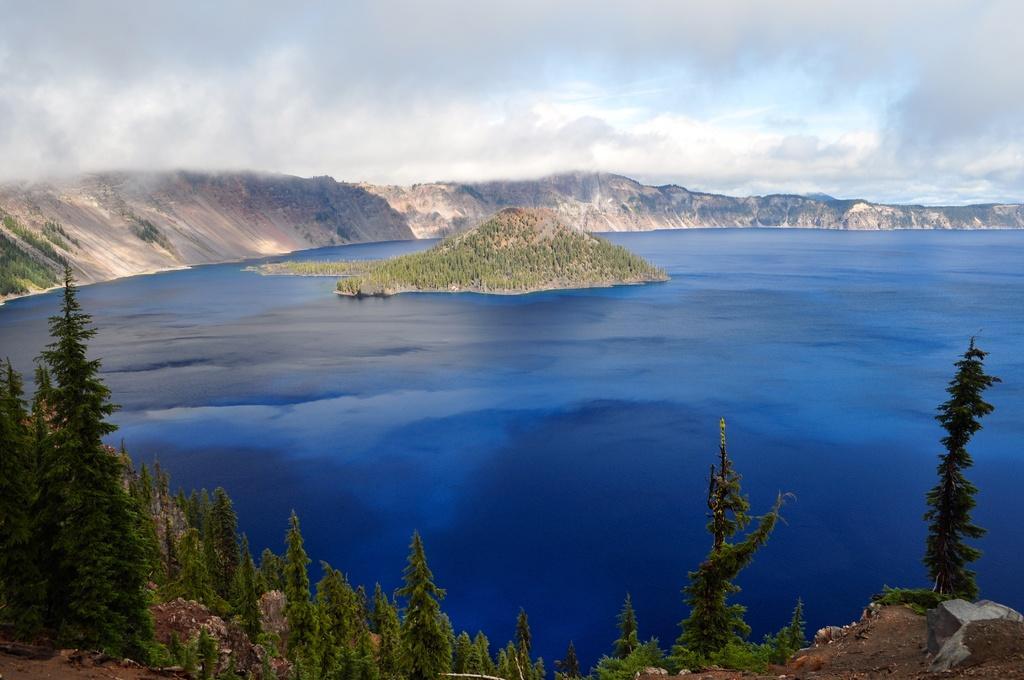How would you summarize this image in a sentence or two? In this picture we can see there are hills, water and the cloudy sky. At the bottom of the image, there are trees. 